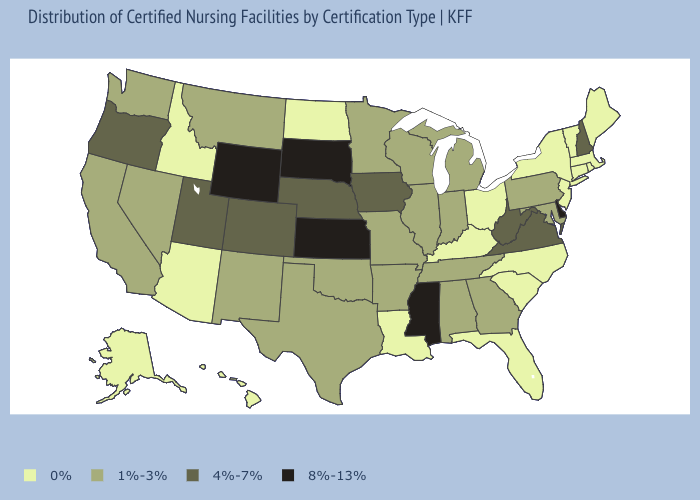Does New Hampshire have the lowest value in the Northeast?
Short answer required. No. What is the value of Nevada?
Concise answer only. 1%-3%. What is the value of Massachusetts?
Keep it brief. 0%. Name the states that have a value in the range 1%-3%?
Answer briefly. Alabama, Arkansas, California, Georgia, Illinois, Indiana, Maryland, Michigan, Minnesota, Missouri, Montana, Nevada, New Mexico, Oklahoma, Pennsylvania, Tennessee, Texas, Washington, Wisconsin. Name the states that have a value in the range 8%-13%?
Short answer required. Delaware, Kansas, Mississippi, South Dakota, Wyoming. Name the states that have a value in the range 1%-3%?
Answer briefly. Alabama, Arkansas, California, Georgia, Illinois, Indiana, Maryland, Michigan, Minnesota, Missouri, Montana, Nevada, New Mexico, Oklahoma, Pennsylvania, Tennessee, Texas, Washington, Wisconsin. What is the highest value in the USA?
Give a very brief answer. 8%-13%. Name the states that have a value in the range 8%-13%?
Write a very short answer. Delaware, Kansas, Mississippi, South Dakota, Wyoming. What is the lowest value in states that border Texas?
Answer briefly. 0%. Does Missouri have the same value as New York?
Give a very brief answer. No. Name the states that have a value in the range 4%-7%?
Answer briefly. Colorado, Iowa, Nebraska, New Hampshire, Oregon, Utah, Virginia, West Virginia. Among the states that border Vermont , does Massachusetts have the lowest value?
Give a very brief answer. Yes. What is the lowest value in the USA?
Answer briefly. 0%. 